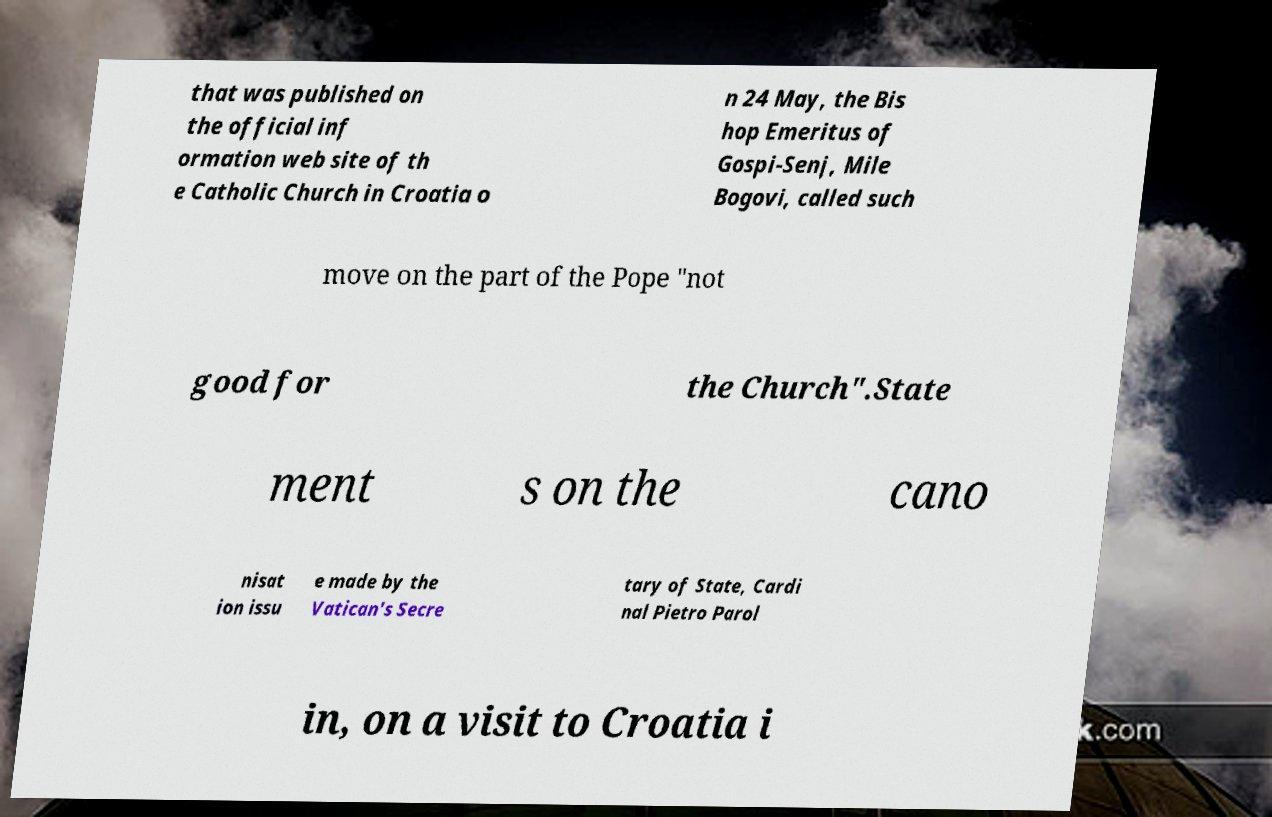What messages or text are displayed in this image? I need them in a readable, typed format. that was published on the official inf ormation web site of th e Catholic Church in Croatia o n 24 May, the Bis hop Emeritus of Gospi-Senj, Mile Bogovi, called such move on the part of the Pope ″not good for the Church″.State ment s on the cano nisat ion issu e made by the Vatican's Secre tary of State, Cardi nal Pietro Parol in, on a visit to Croatia i 